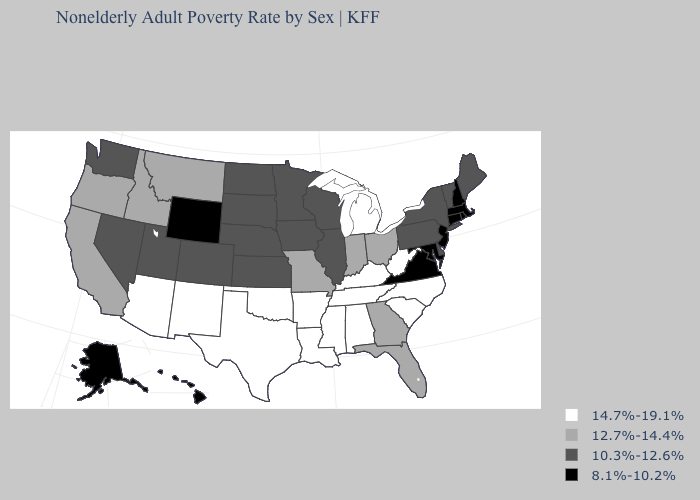Name the states that have a value in the range 8.1%-10.2%?
Quick response, please. Alaska, Connecticut, Hawaii, Maryland, Massachusetts, New Hampshire, New Jersey, Rhode Island, Virginia, Wyoming. What is the lowest value in the West?
Concise answer only. 8.1%-10.2%. What is the highest value in the USA?
Be succinct. 14.7%-19.1%. Among the states that border Indiana , does Kentucky have the highest value?
Keep it brief. Yes. Among the states that border California , does Nevada have the lowest value?
Give a very brief answer. Yes. Name the states that have a value in the range 8.1%-10.2%?
Keep it brief. Alaska, Connecticut, Hawaii, Maryland, Massachusetts, New Hampshire, New Jersey, Rhode Island, Virginia, Wyoming. What is the lowest value in the West?
Be succinct. 8.1%-10.2%. Does the first symbol in the legend represent the smallest category?
Keep it brief. No. Name the states that have a value in the range 10.3%-12.6%?
Concise answer only. Colorado, Delaware, Illinois, Iowa, Kansas, Maine, Minnesota, Nebraska, Nevada, New York, North Dakota, Pennsylvania, South Dakota, Utah, Vermont, Washington, Wisconsin. Does Nebraska have a higher value than Alaska?
Quick response, please. Yes. What is the lowest value in the USA?
Be succinct. 8.1%-10.2%. Name the states that have a value in the range 14.7%-19.1%?
Give a very brief answer. Alabama, Arizona, Arkansas, Kentucky, Louisiana, Michigan, Mississippi, New Mexico, North Carolina, Oklahoma, South Carolina, Tennessee, Texas, West Virginia. Name the states that have a value in the range 14.7%-19.1%?
Answer briefly. Alabama, Arizona, Arkansas, Kentucky, Louisiana, Michigan, Mississippi, New Mexico, North Carolina, Oklahoma, South Carolina, Tennessee, Texas, West Virginia. How many symbols are there in the legend?
Quick response, please. 4. Among the states that border Oklahoma , does Texas have the lowest value?
Quick response, please. No. 